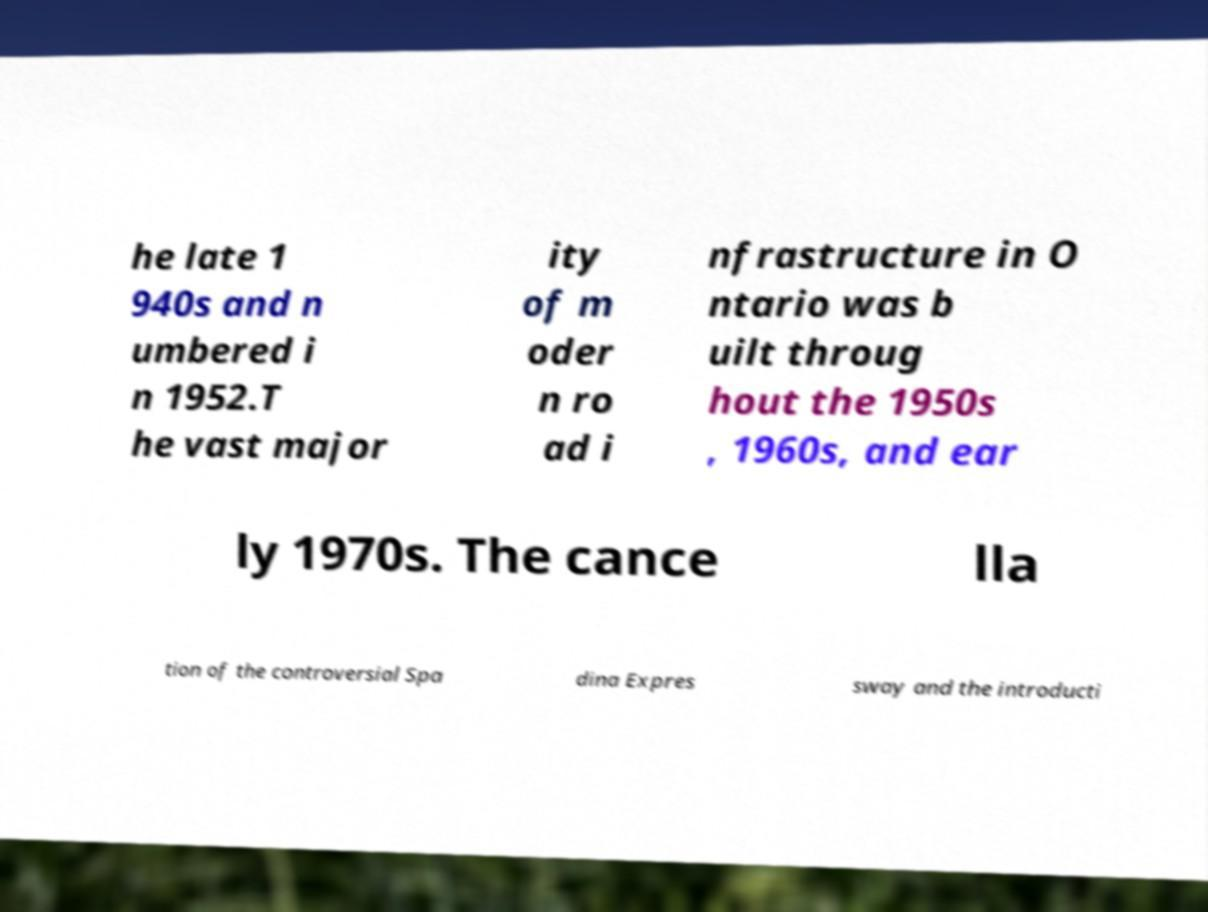What messages or text are displayed in this image? I need them in a readable, typed format. he late 1 940s and n umbered i n 1952.T he vast major ity of m oder n ro ad i nfrastructure in O ntario was b uilt throug hout the 1950s , 1960s, and ear ly 1970s. The cance lla tion of the controversial Spa dina Expres sway and the introducti 